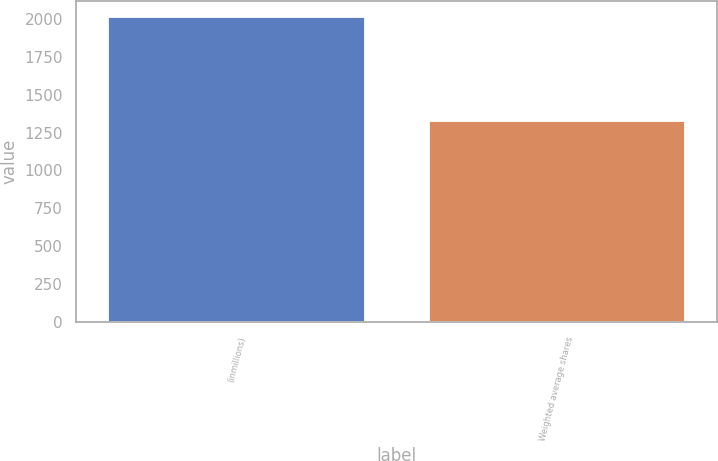<chart> <loc_0><loc_0><loc_500><loc_500><bar_chart><fcel>(inmillions)<fcel>Weighted average shares<nl><fcel>2014<fcel>1324.3<nl></chart> 